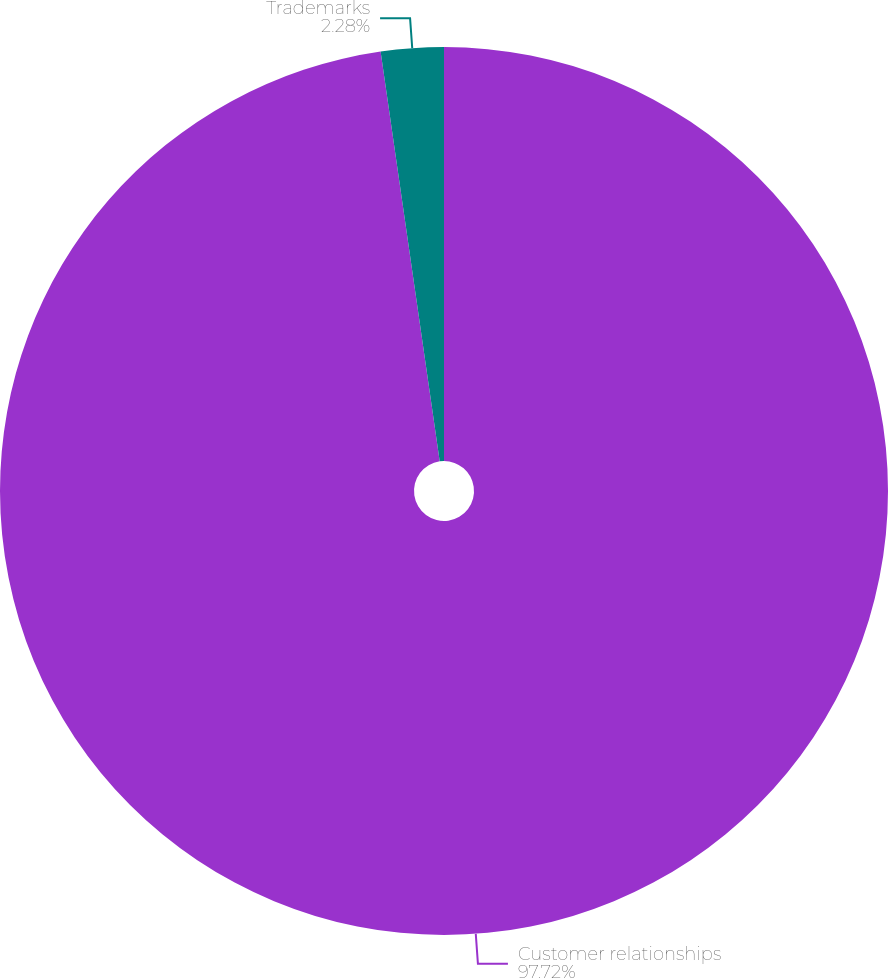<chart> <loc_0><loc_0><loc_500><loc_500><pie_chart><fcel>Customer relationships<fcel>Trademarks<nl><fcel>97.72%<fcel>2.28%<nl></chart> 